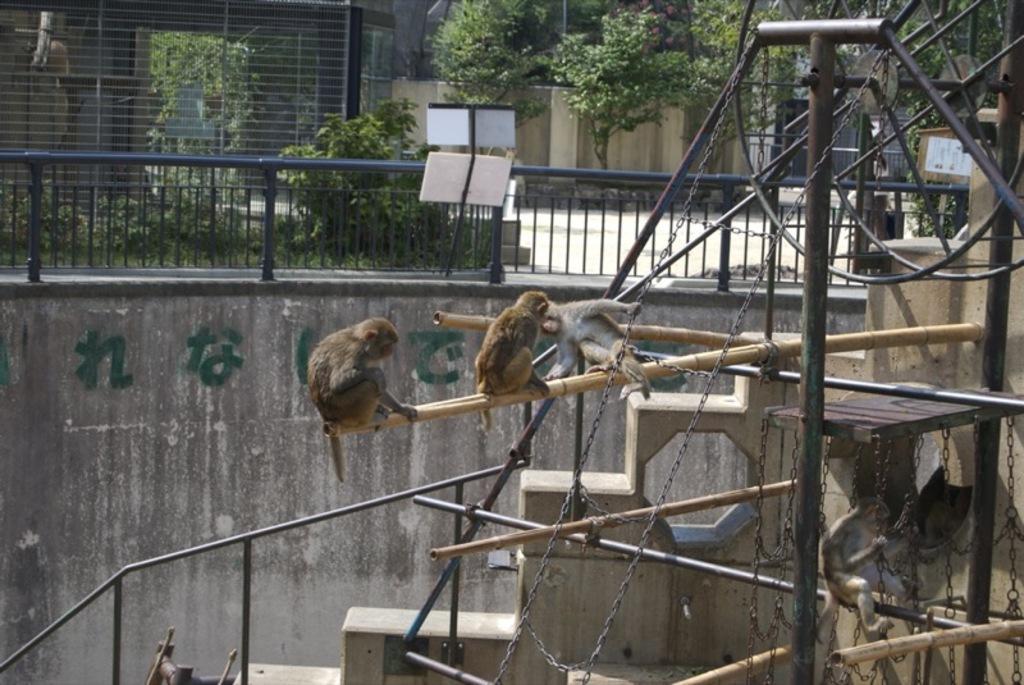Can you describe this image briefly? In this image we can see monkeys, wooden sticks, steps, poles, chains, walls, railing, plants, trees, grille, and other objects. 